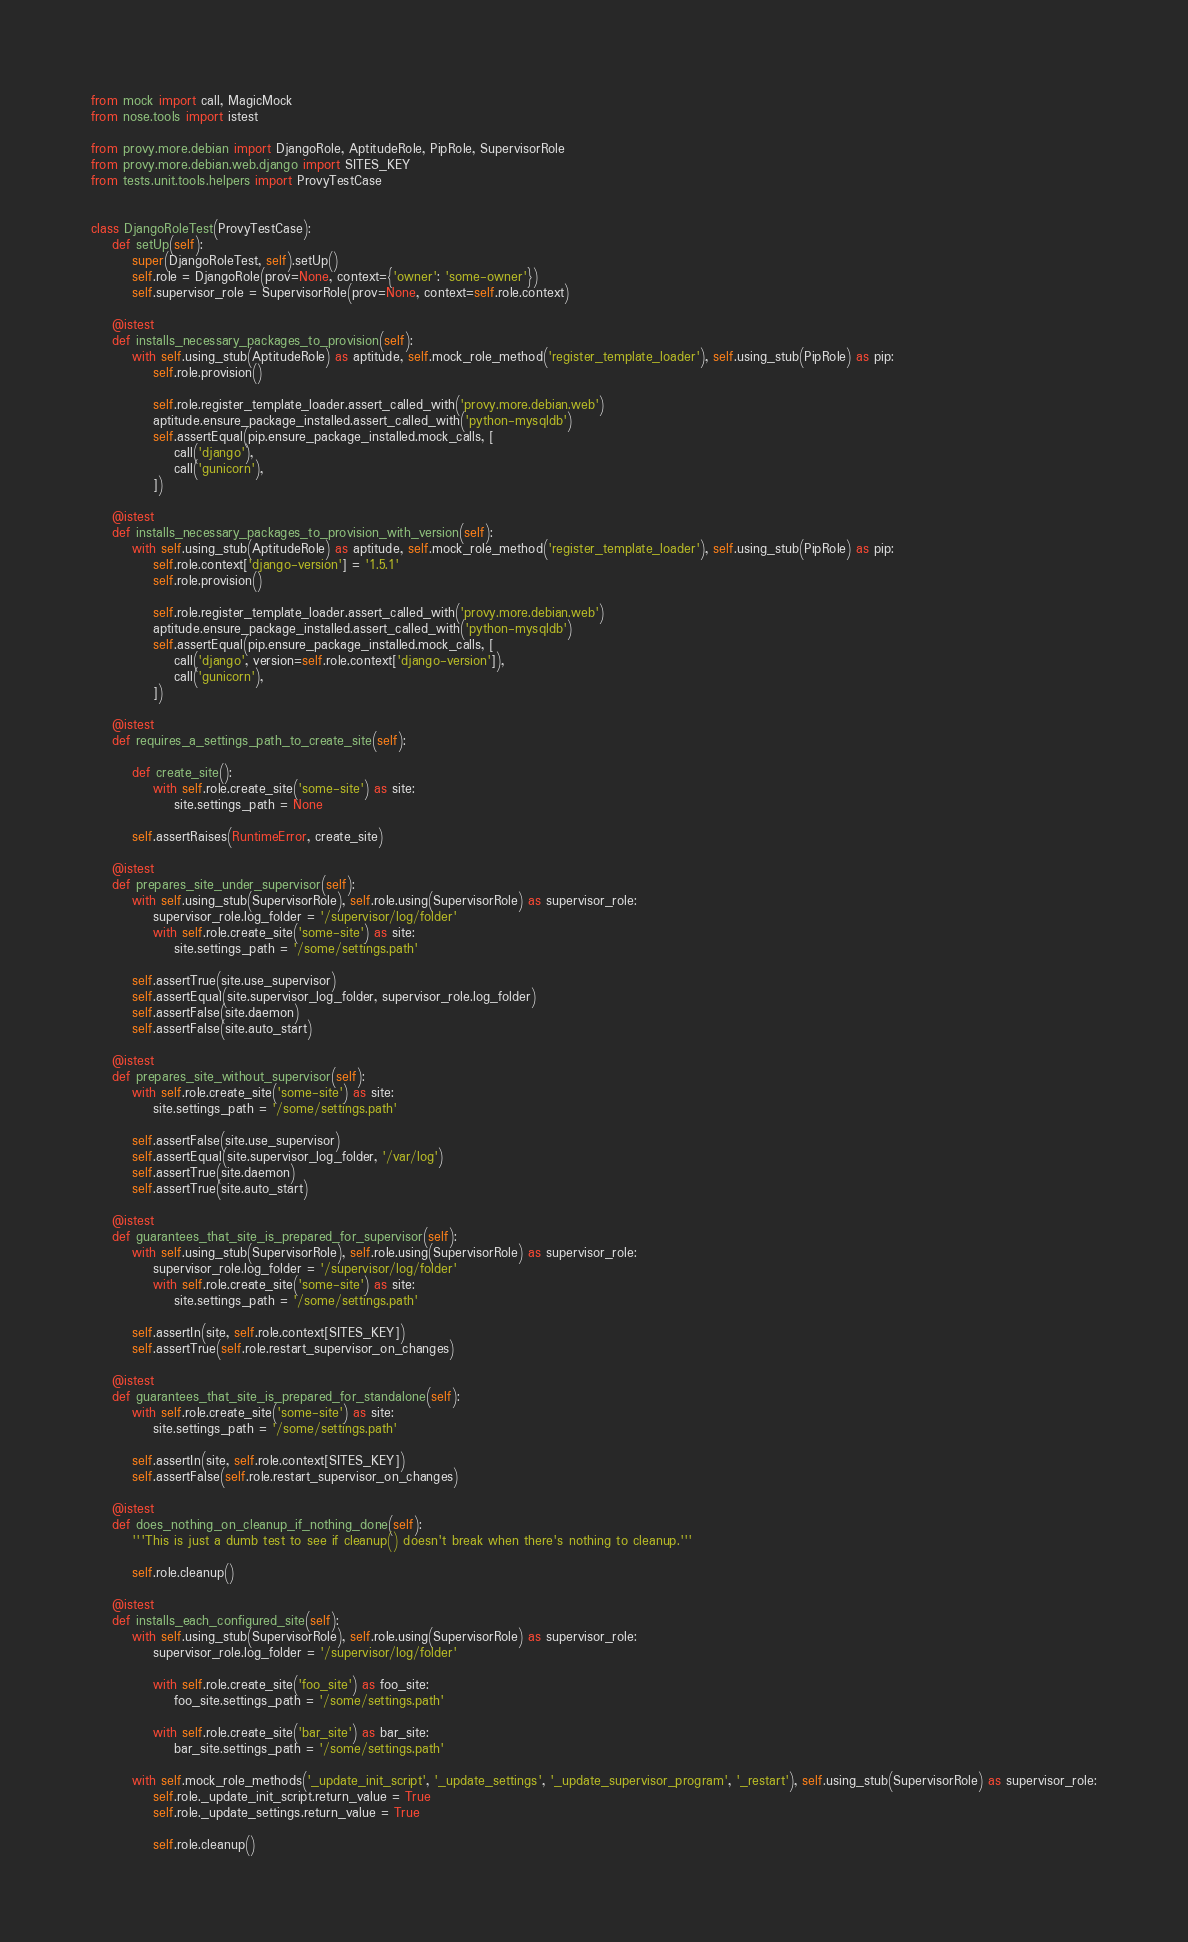<code> <loc_0><loc_0><loc_500><loc_500><_Python_>from mock import call, MagicMock
from nose.tools import istest

from provy.more.debian import DjangoRole, AptitudeRole, PipRole, SupervisorRole
from provy.more.debian.web.django import SITES_KEY
from tests.unit.tools.helpers import ProvyTestCase


class DjangoRoleTest(ProvyTestCase):
    def setUp(self):
        super(DjangoRoleTest, self).setUp()
        self.role = DjangoRole(prov=None, context={'owner': 'some-owner'})
        self.supervisor_role = SupervisorRole(prov=None, context=self.role.context)

    @istest
    def installs_necessary_packages_to_provision(self):
        with self.using_stub(AptitudeRole) as aptitude, self.mock_role_method('register_template_loader'), self.using_stub(PipRole) as pip:
            self.role.provision()

            self.role.register_template_loader.assert_called_with('provy.more.debian.web')
            aptitude.ensure_package_installed.assert_called_with('python-mysqldb')
            self.assertEqual(pip.ensure_package_installed.mock_calls, [
                call('django'),
                call('gunicorn'),
            ])

    @istest
    def installs_necessary_packages_to_provision_with_version(self):
        with self.using_stub(AptitudeRole) as aptitude, self.mock_role_method('register_template_loader'), self.using_stub(PipRole) as pip:
            self.role.context['django-version'] = '1.5.1'
            self.role.provision()

            self.role.register_template_loader.assert_called_with('provy.more.debian.web')
            aptitude.ensure_package_installed.assert_called_with('python-mysqldb')
            self.assertEqual(pip.ensure_package_installed.mock_calls, [
                call('django', version=self.role.context['django-version']),
                call('gunicorn'),
            ])

    @istest
    def requires_a_settings_path_to_create_site(self):

        def create_site():
            with self.role.create_site('some-site') as site:
                site.settings_path = None

        self.assertRaises(RuntimeError, create_site)

    @istest
    def prepares_site_under_supervisor(self):
        with self.using_stub(SupervisorRole), self.role.using(SupervisorRole) as supervisor_role:
            supervisor_role.log_folder = '/supervisor/log/folder'
            with self.role.create_site('some-site') as site:
                site.settings_path = '/some/settings.path'

        self.assertTrue(site.use_supervisor)
        self.assertEqual(site.supervisor_log_folder, supervisor_role.log_folder)
        self.assertFalse(site.daemon)
        self.assertFalse(site.auto_start)

    @istest
    def prepares_site_without_supervisor(self):
        with self.role.create_site('some-site') as site:
            site.settings_path = '/some/settings.path'

        self.assertFalse(site.use_supervisor)
        self.assertEqual(site.supervisor_log_folder, '/var/log')
        self.assertTrue(site.daemon)
        self.assertTrue(site.auto_start)

    @istest
    def guarantees_that_site_is_prepared_for_supervisor(self):
        with self.using_stub(SupervisorRole), self.role.using(SupervisorRole) as supervisor_role:
            supervisor_role.log_folder = '/supervisor/log/folder'
            with self.role.create_site('some-site') as site:
                site.settings_path = '/some/settings.path'

        self.assertIn(site, self.role.context[SITES_KEY])
        self.assertTrue(self.role.restart_supervisor_on_changes)

    @istest
    def guarantees_that_site_is_prepared_for_standalone(self):
        with self.role.create_site('some-site') as site:
            site.settings_path = '/some/settings.path'

        self.assertIn(site, self.role.context[SITES_KEY])
        self.assertFalse(self.role.restart_supervisor_on_changes)

    @istest
    def does_nothing_on_cleanup_if_nothing_done(self):
        '''This is just a dumb test to see if cleanup() doesn't break when there's nothing to cleanup.'''

        self.role.cleanup()

    @istest
    def installs_each_configured_site(self):
        with self.using_stub(SupervisorRole), self.role.using(SupervisorRole) as supervisor_role:
            supervisor_role.log_folder = '/supervisor/log/folder'

            with self.role.create_site('foo_site') as foo_site:
                foo_site.settings_path = '/some/settings.path'

            with self.role.create_site('bar_site') as bar_site:
                bar_site.settings_path = '/some/settings.path'

        with self.mock_role_methods('_update_init_script', '_update_settings', '_update_supervisor_program', '_restart'), self.using_stub(SupervisorRole) as supervisor_role:
            self.role._update_init_script.return_value = True
            self.role._update_settings.return_value = True

            self.role.cleanup()
</code> 